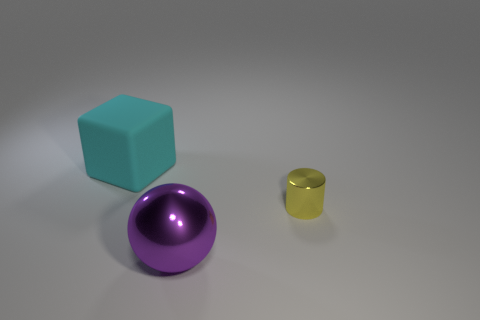Are there more spheres that are in front of the large cyan thing than big purple metallic cubes?
Ensure brevity in your answer.  Yes. What number of big objects are in front of the big thing that is right of the big cyan object that is on the left side of the small shiny cylinder?
Offer a terse response. 0. What is the thing to the left of the purple metallic thing made of?
Provide a succinct answer. Rubber. There is a object that is left of the tiny yellow cylinder and behind the sphere; what shape is it?
Give a very brief answer. Cube. What is the small yellow cylinder made of?
Give a very brief answer. Metal. How many balls are purple metallic objects or tiny objects?
Provide a short and direct response. 1. Do the tiny thing and the big block have the same material?
Offer a terse response. No. The object that is both left of the cylinder and in front of the cyan block is made of what material?
Provide a short and direct response. Metal. Are there an equal number of metallic spheres that are behind the tiny cylinder and red things?
Give a very brief answer. Yes. What number of objects are either objects that are to the right of the big purple shiny sphere or large cyan shiny blocks?
Provide a succinct answer. 1. 